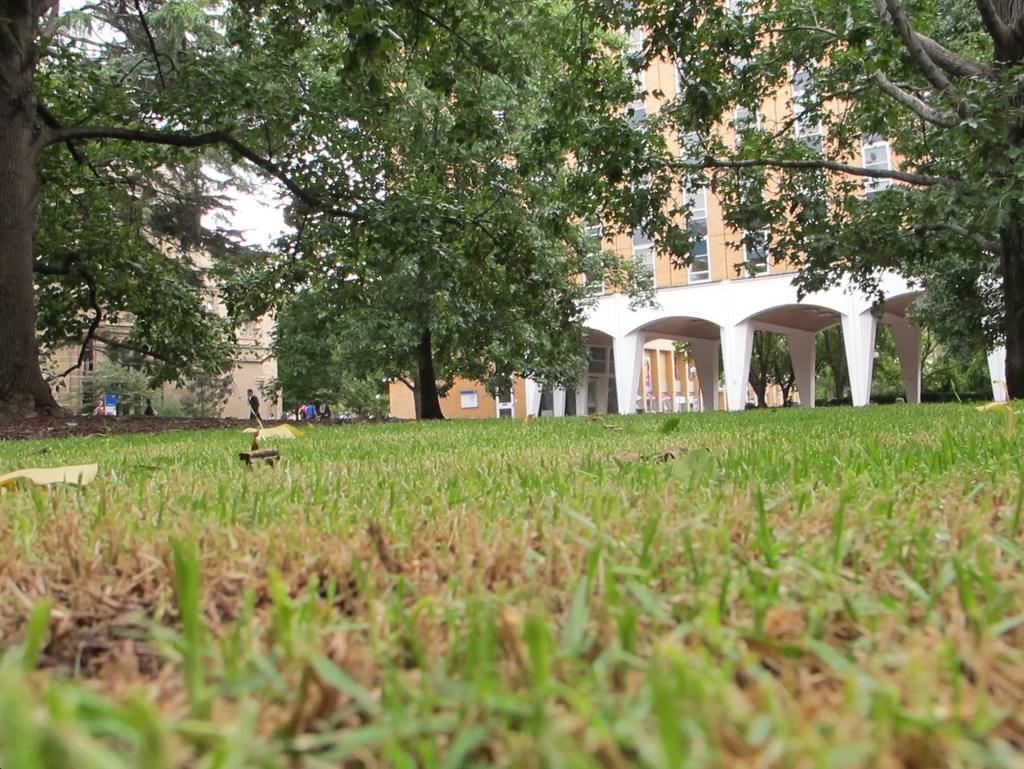What type of vegetation can be seen in the image? There is grass and trees in the image. What are the persons in the image doing? The persons in the image are walking in the background. What can be seen in the distance in the image? There are buildings in the background of the image. Can you see a tiger hiding in the grass in the image? No, there is no tiger present in the image. What type of tool is being used by the persons in the image? The provided facts do not mention any tools being used by the persons in the image. 